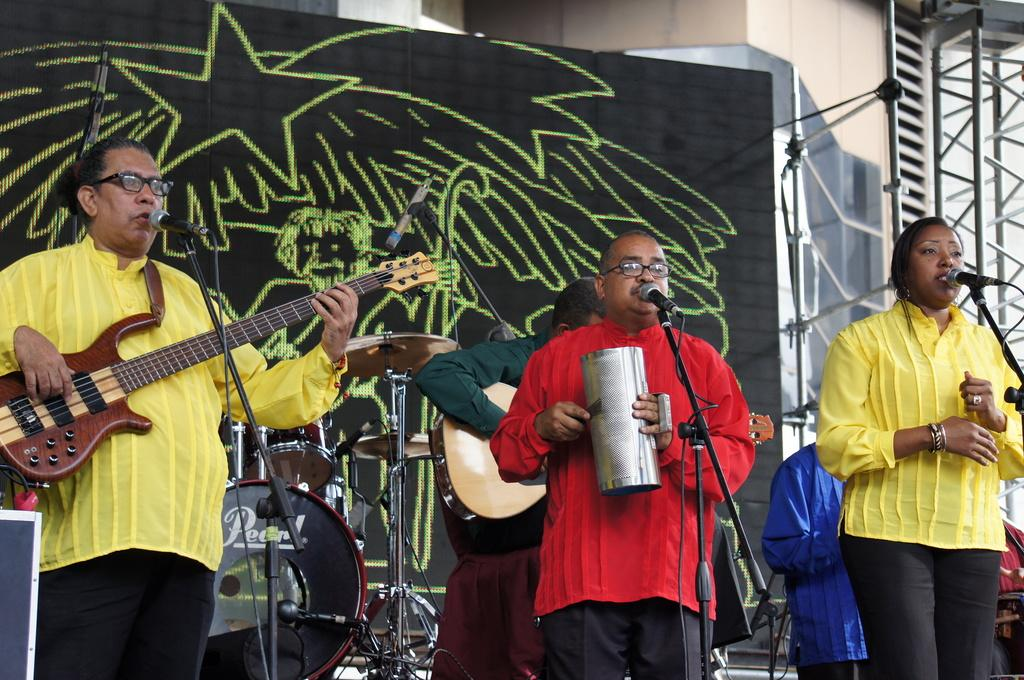What activity is taking place in the image? Musicians are performing in the image. What tools are being used by the musicians? Musical instruments are present in the image. What can be seen on the wall in the background of the image? There is a board with a drawing in the background of the image. What architectural features are visible in the background of the image? There are stands and a wall in the background of the image. How much did the parcel increase in size during the performance in the image? There is no parcel present in the image, so it cannot be determined if it increased in size or not. 